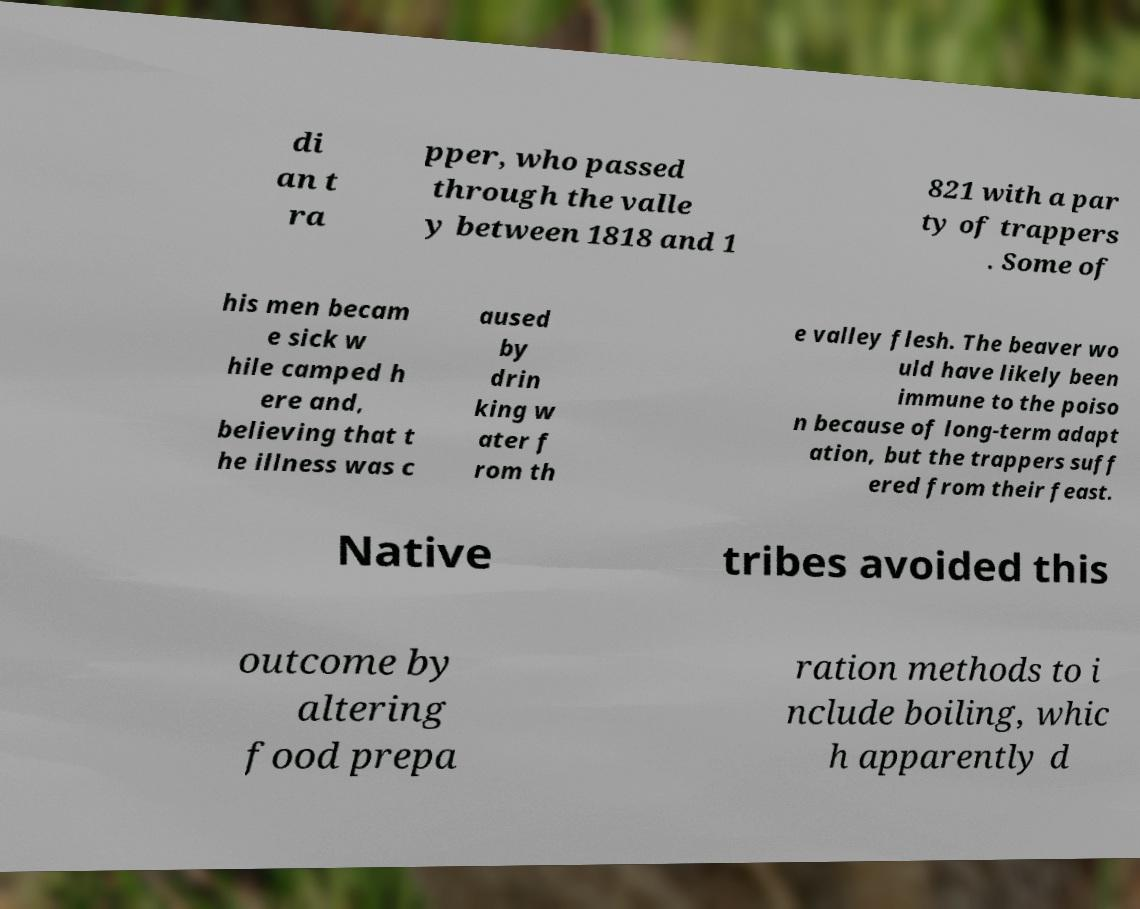Please identify and transcribe the text found in this image. di an t ra pper, who passed through the valle y between 1818 and 1 821 with a par ty of trappers . Some of his men becam e sick w hile camped h ere and, believing that t he illness was c aused by drin king w ater f rom th e valley flesh. The beaver wo uld have likely been immune to the poiso n because of long-term adapt ation, but the trappers suff ered from their feast. Native tribes avoided this outcome by altering food prepa ration methods to i nclude boiling, whic h apparently d 